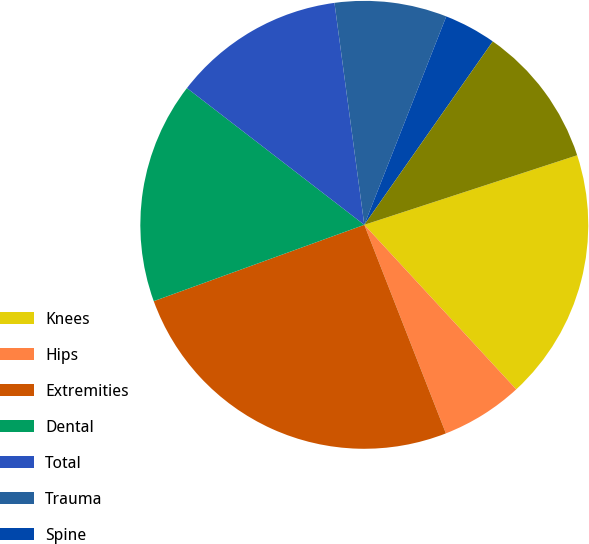Convert chart. <chart><loc_0><loc_0><loc_500><loc_500><pie_chart><fcel>Knees<fcel>Hips<fcel>Extremities<fcel>Dental<fcel>Total<fcel>Trauma<fcel>Spine<fcel>OSP and Other<nl><fcel>18.16%<fcel>5.93%<fcel>25.4%<fcel>15.99%<fcel>12.42%<fcel>8.09%<fcel>3.76%<fcel>10.25%<nl></chart> 